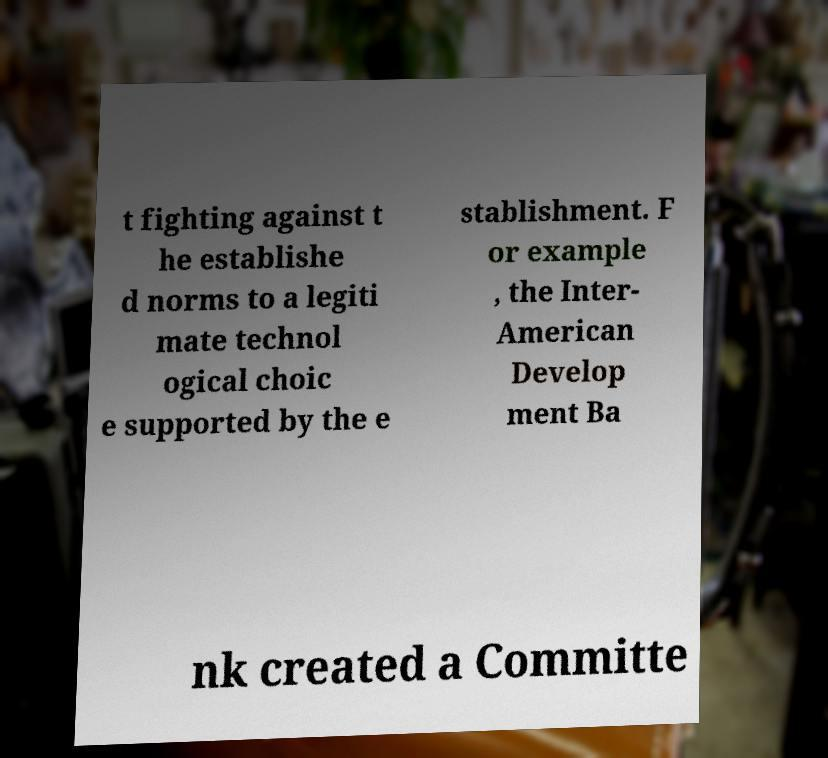Can you accurately transcribe the text from the provided image for me? t fighting against t he establishe d norms to a legiti mate technol ogical choic e supported by the e stablishment. F or example , the Inter- American Develop ment Ba nk created a Committe 